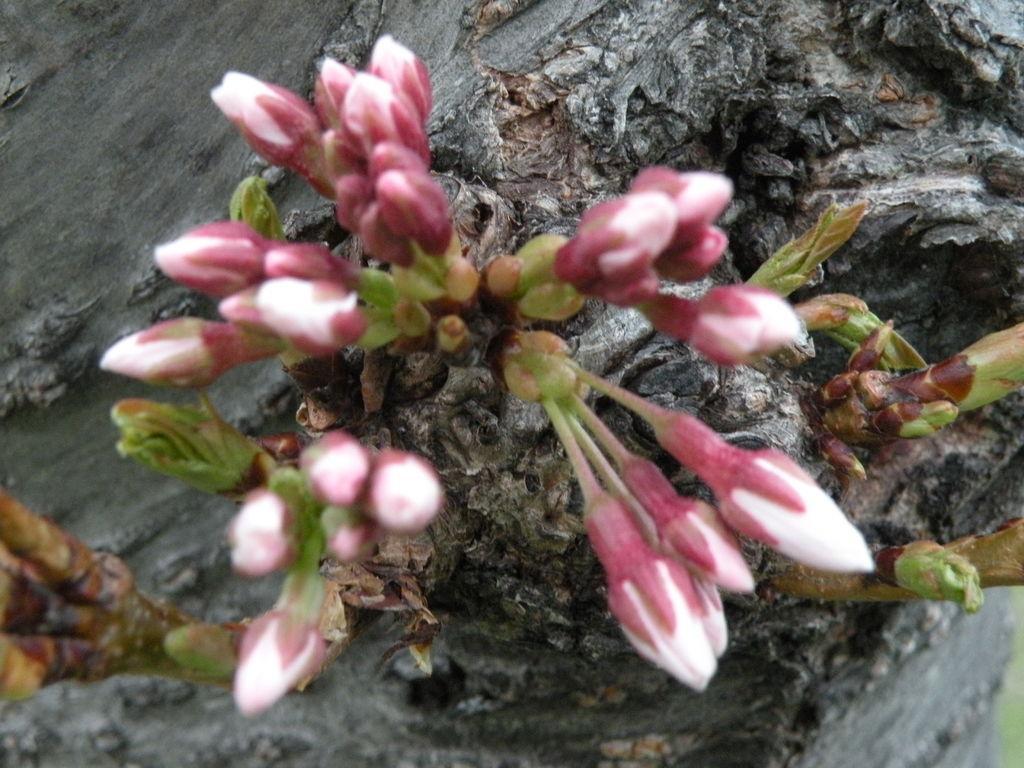Could you give a brief overview of what you see in this image? In this image we can see flower buds on the bark of a tree. 